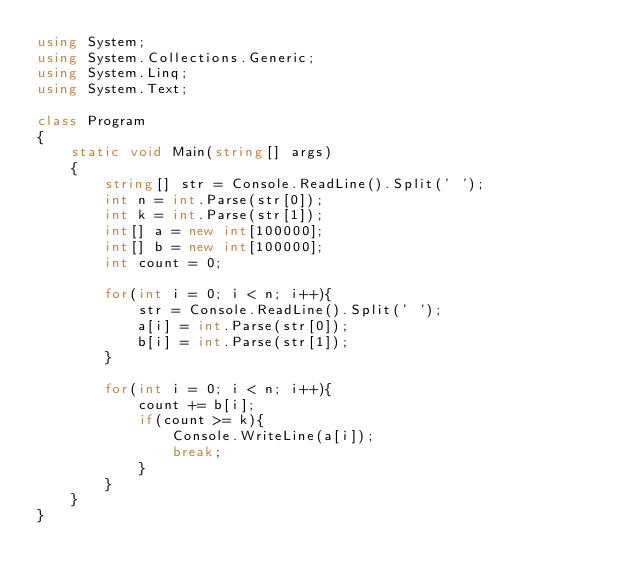Convert code to text. <code><loc_0><loc_0><loc_500><loc_500><_C#_>using System;
using System.Collections.Generic;
using System.Linq;
using System.Text;

class Program
{
    static void Main(string[] args)
    {
        string[] str = Console.ReadLine().Split(' ');
        int n = int.Parse(str[0]);
        int k = int.Parse(str[1]);
        int[] a = new int[100000];
        int[] b = new int[100000];
        int count = 0;

        for(int i = 0; i < n; i++){
            str = Console.ReadLine().Split(' ');
            a[i] = int.Parse(str[0]);
            b[i] = int.Parse(str[1]);
        }

        for(int i = 0; i < n; i++){
            count += b[i];
            if(count >= k){
                Console.WriteLine(a[i]);
                break;
            }
        }
    }
}</code> 